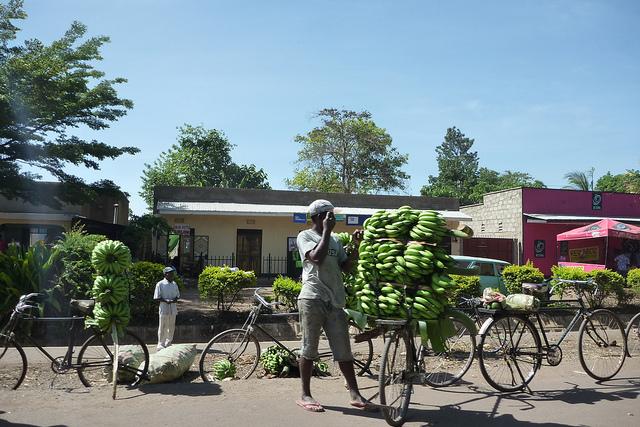Where are the bananas?
Keep it brief. On bike. Do you see an umbrella?
Answer briefly. Yes. What is on top of the bicycle with the person next to it?
Answer briefly. Bananas. 